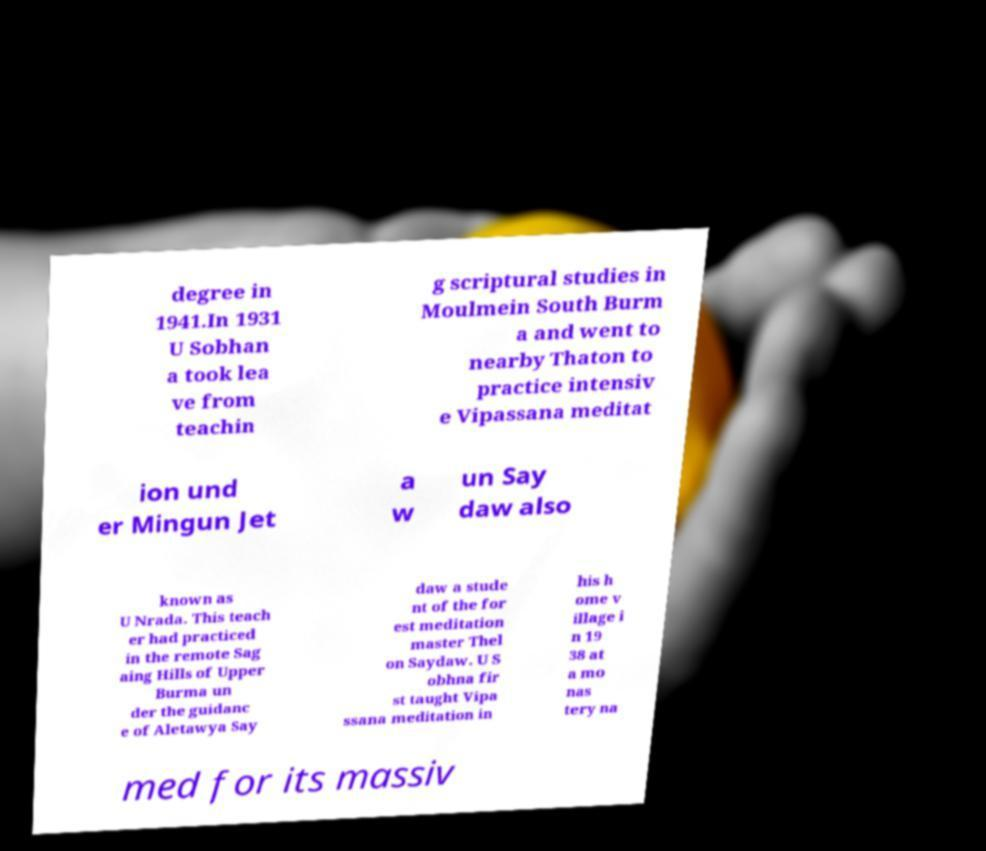Can you read and provide the text displayed in the image?This photo seems to have some interesting text. Can you extract and type it out for me? degree in 1941.In 1931 U Sobhan a took lea ve from teachin g scriptural studies in Moulmein South Burm a and went to nearby Thaton to practice intensiv e Vipassana meditat ion und er Mingun Jet a w un Say daw also known as U Nrada. This teach er had practiced in the remote Sag aing Hills of Upper Burma un der the guidanc e of Aletawya Say daw a stude nt of the for est meditation master Thel on Saydaw. U S obhna fir st taught Vipa ssana meditation in his h ome v illage i n 19 38 at a mo nas tery na med for its massiv 